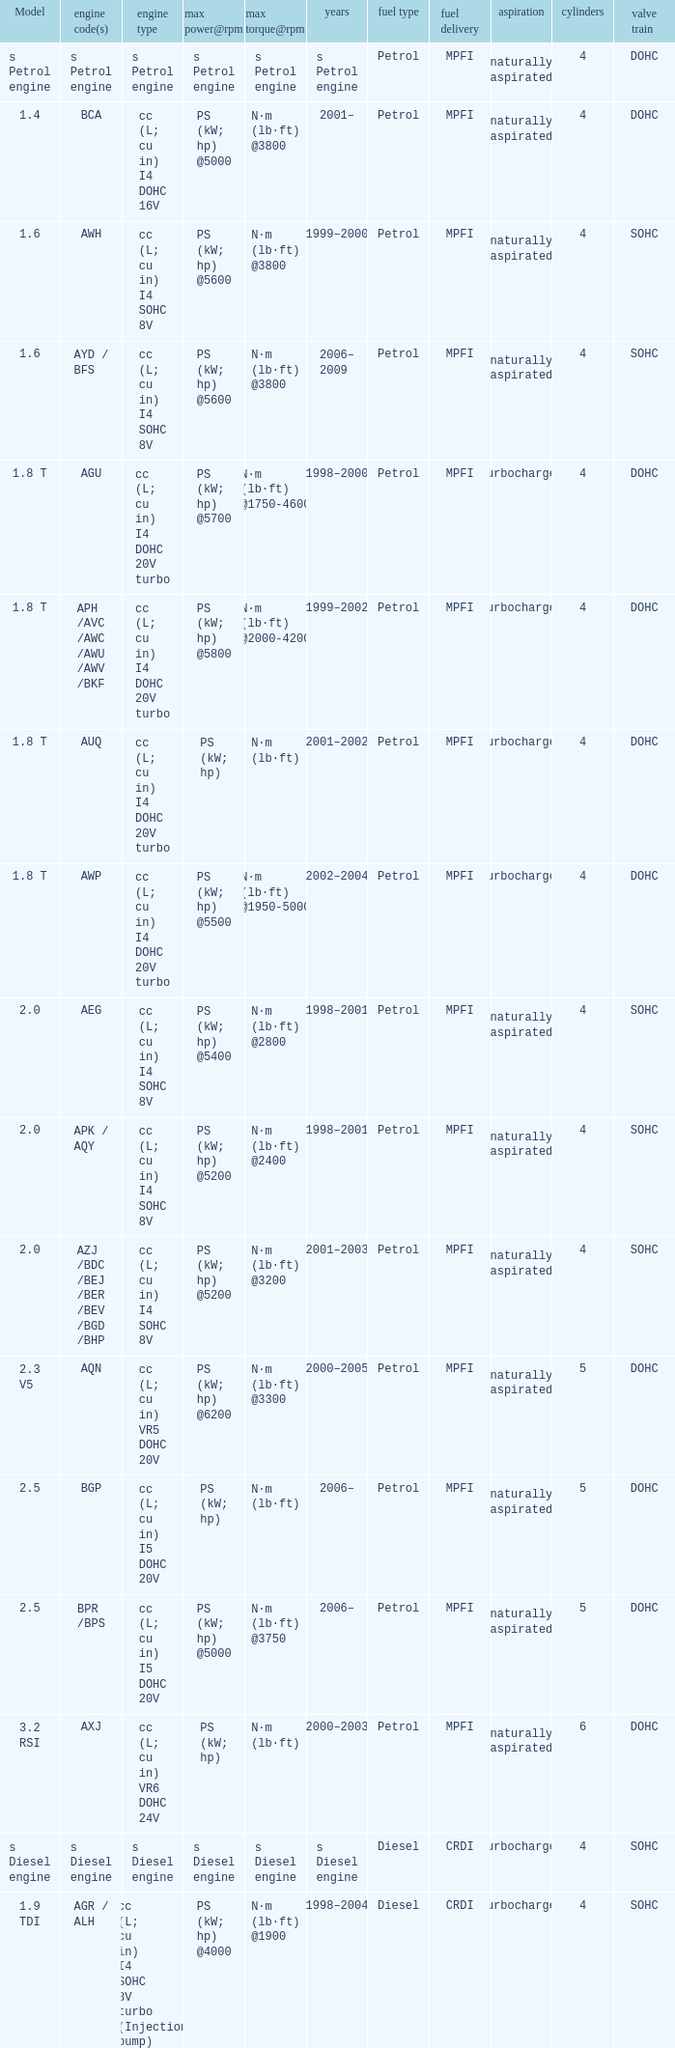What was the peak torque and its corresponding rpm for the 2.5 model engine that had a maximum power output of ps (kw; hp) at 5000 rpm? N·m (lb·ft) @3750. 